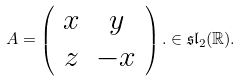Convert formula to latex. <formula><loc_0><loc_0><loc_500><loc_500>A = \left ( \begin{array} { c c } x & y \\ z & - x \end{array} \right ) . \in \mathfrak { s l } _ { 2 } ( \mathbb { R } ) .</formula> 